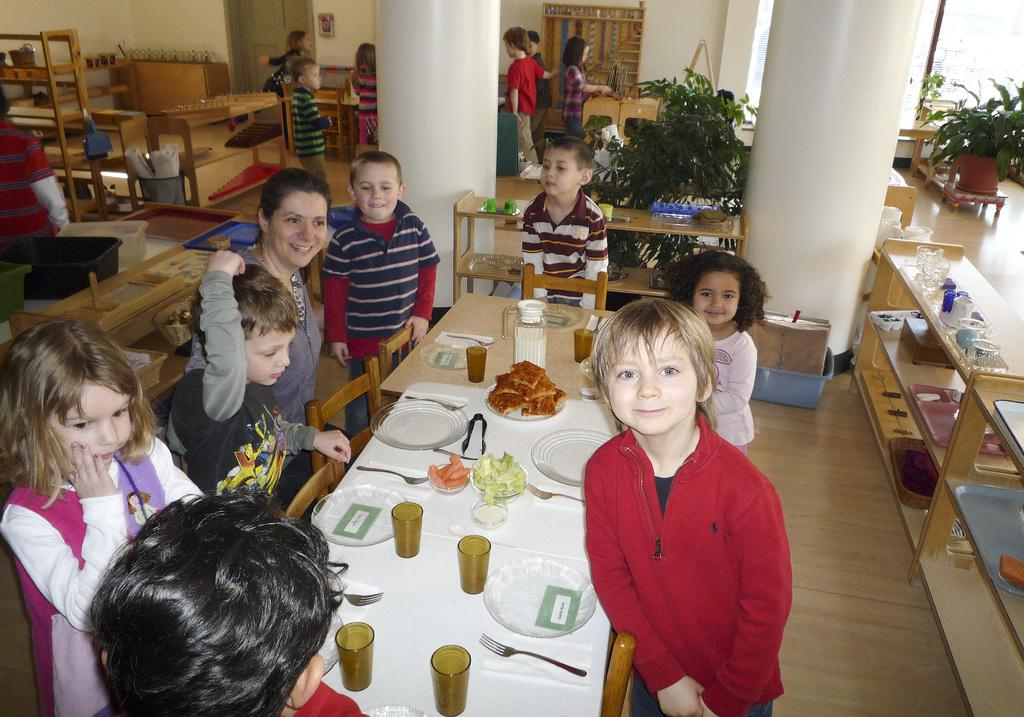What is the main piece of furniture in the image? There is a table in the image. What items are placed on the table? There are plates, glasses, and food on the table. Are there any people in the image? Yes, people are standing on the left and right sides of the image. What can be seen in the background of the image? There are plants and pillars visible in the background. What is the value of the ornament hanging from the ceiling in the image? There is no ornament hanging from the ceiling in the image. The image only shows a table with plates, glasses, and food, as well as people standing on the left and right sides, and plants and pillars in the background. 